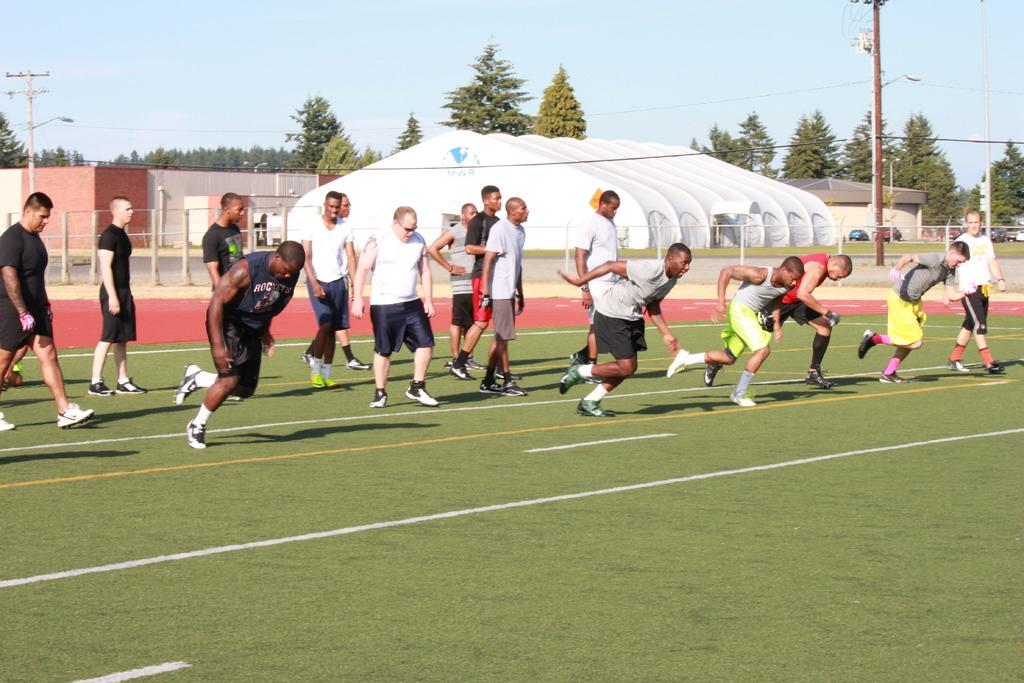What are the people in the image doing? There are people running on the ground and people standing in the image. What can be seen in the background of the image? There are buildings, poles, vehicles, and utility poles in the background. What is visible in the sky in the image? The sky is visible in the image. Can you tell me how many legs are visible in the image? There is no specific mention of legs in the image, so it is not possible to determine the number of legs visible. 